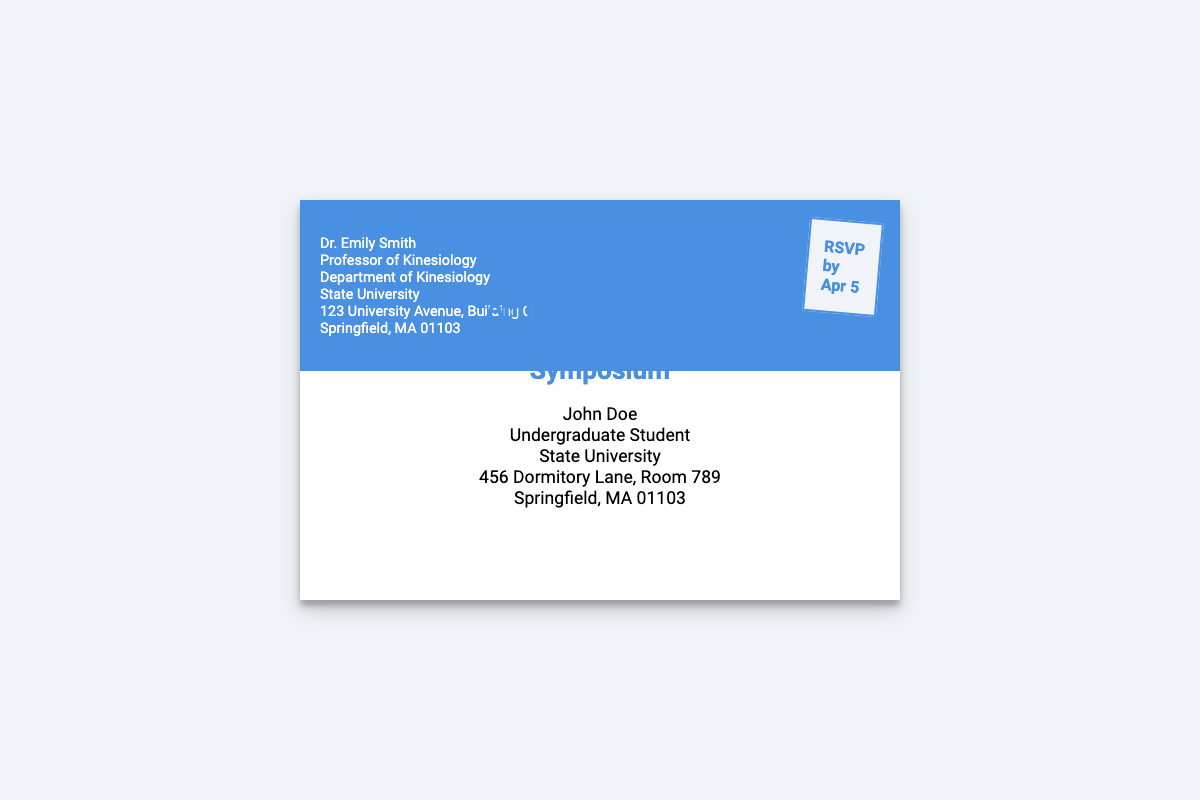What is the name of the sender? The sender's name is listed at the top of the envelope.
Answer: Dr. Emily Smith What is the title of the event? The title of the event is highlighted in the center of the envelope.
Answer: Annual Kinesiology Department Symposium What is the RSVP deadline? The RSVP deadline is indicated in the stamp section of the envelope.
Answer: Apr 5 Who is the recipient of the invitation? The recipient's name is mentioned below the event title.
Answer: John Doe Where is the sender's department located? The sender's department address is specified in the sender's information.
Answer: Department of Kinesiology What is the room number for the recipient? The room number is provided in the recipient's address on the envelope.
Answer: Room 789 How many years of experience does Dr. Emily Smith have? This information may not be directly available in the envelope, but reasoning from common academic norms can be utilized.
Answer: Not specified What color is used for the sender's section? The background color for the sender's section is mentioned in the styling of the envelope.
Answer: #4a90e2 What is the educational institution mentioned in the document? The educational institution is referred to in both sender and recipient sections.
Answer: State University 